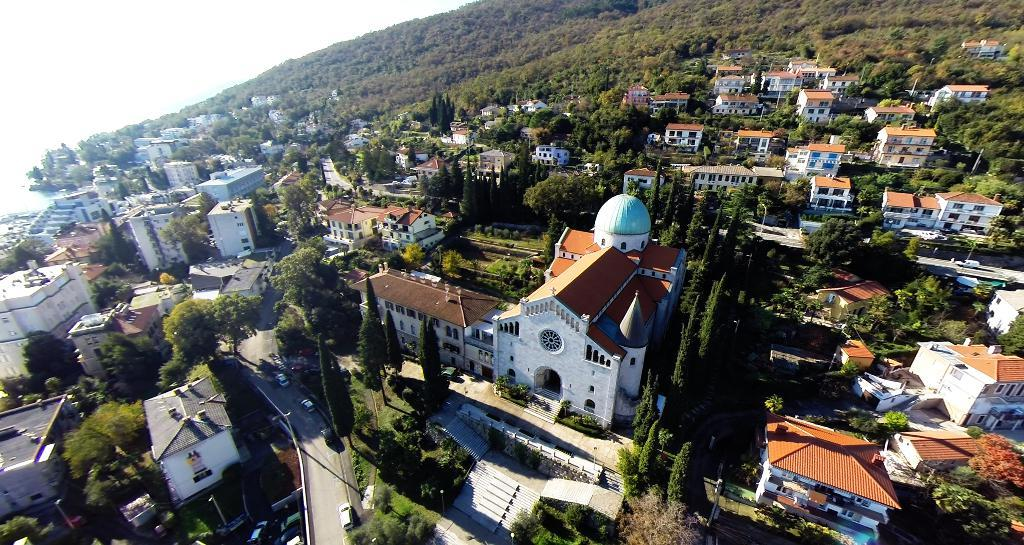What type of structures can be seen in the image? There are buildings in the image. What natural elements are present in the image? There are trees, plants, and grass in the image. What man-made elements are present in the image? There are roads, poles, and vehicles in the image. What part of the natural environment is visible in the image? The sky is visible in the image. How are the vehicles positioned in the image? Vehicles are on the roads in the image. What is the form of the limit or border in the image? There is no mention of a limit or border in the image; it features buildings, trees, vehicles, roads, poles, plants, grass, and sky. 